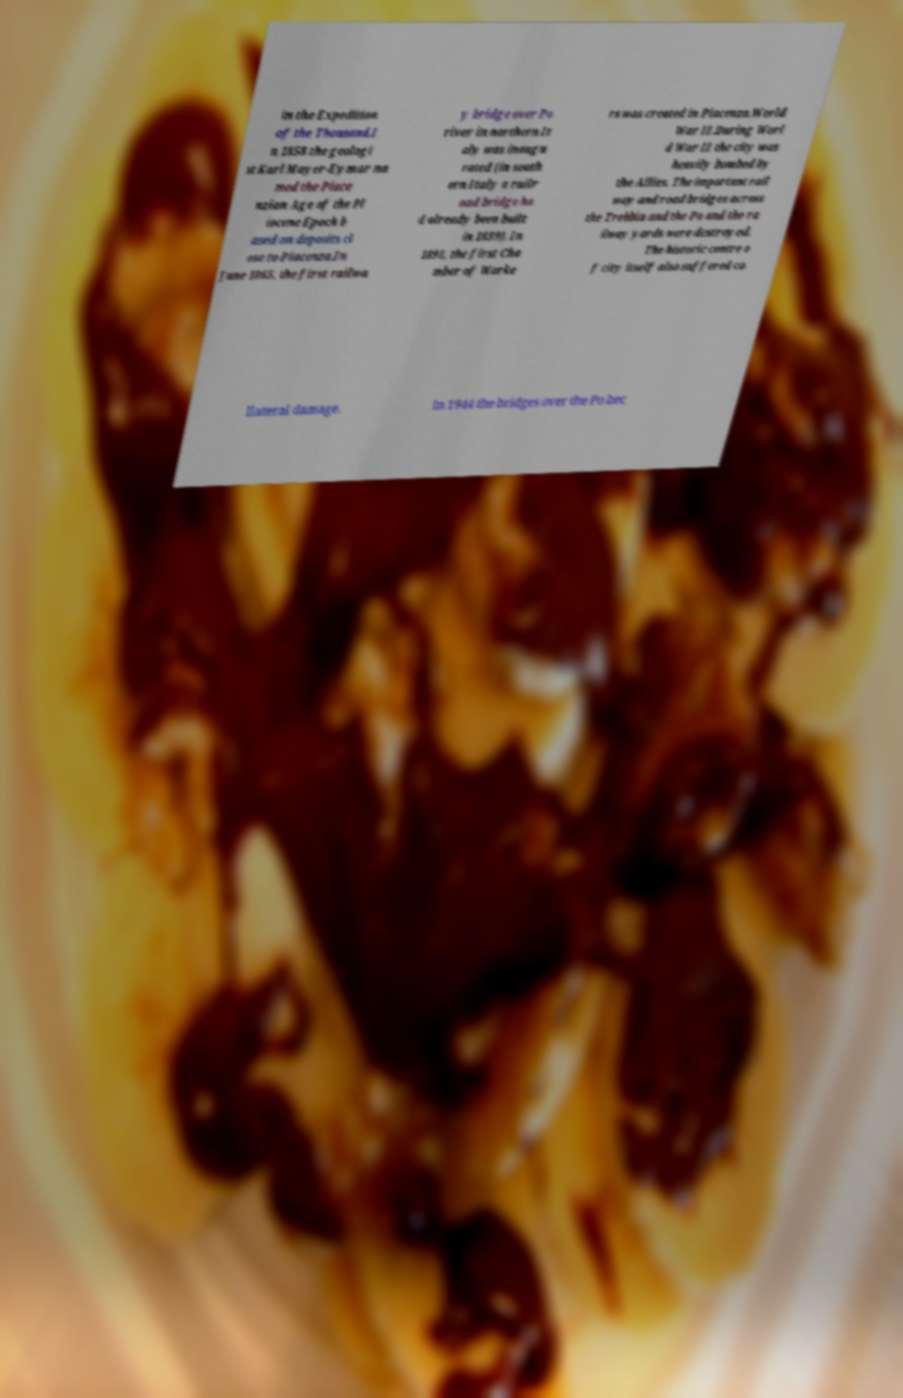For documentation purposes, I need the text within this image transcribed. Could you provide that? in the Expedition of the Thousand.I n 1858 the geologi st Karl Mayer-Eymar na med the Piace nzian Age of the Pl iocene Epoch b ased on deposits cl ose to Piacenza.In June 1865, the first railwa y bridge over Po river in northern It aly was inaugu rated (in south ern Italy a railr oad bridge ha d already been built in 1839). In 1891, the first Cha mber of Worke rs was created in Piacenza.World War II.During Worl d War II the city was heavily bombed by the Allies. The important rail way and road bridges across the Trebbia and the Po and the ra ilway yards were destroyed. The historic centre o f city itself also suffered co llateral damage. In 1944 the bridges over the Po bec 